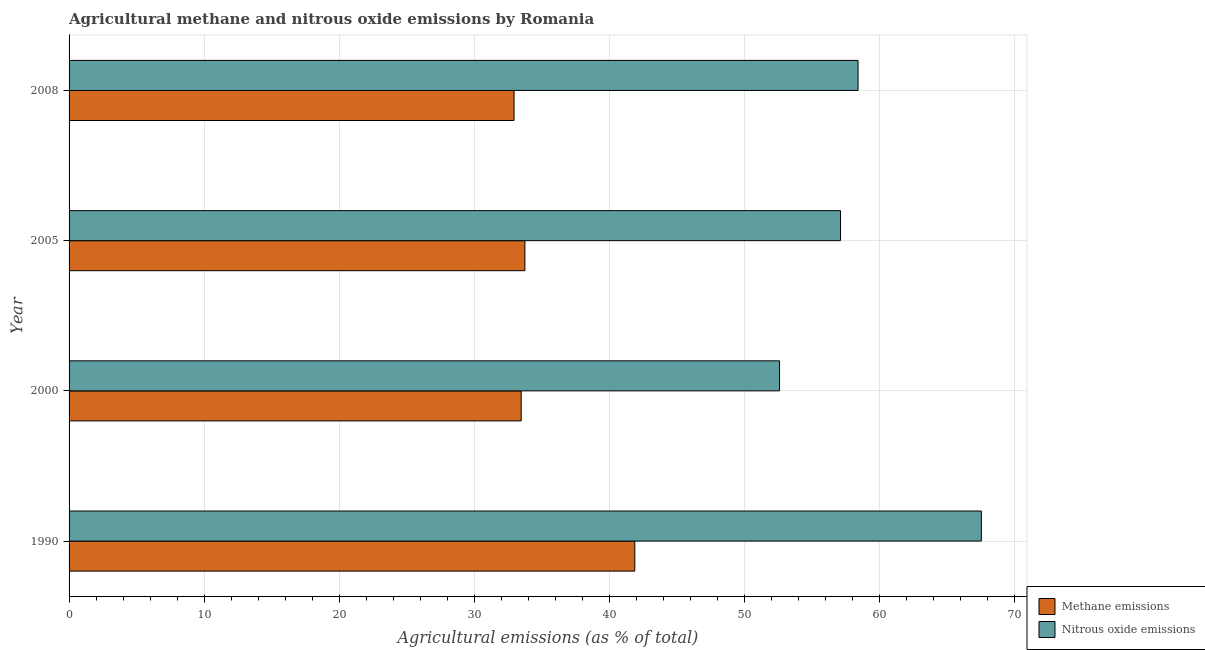How many bars are there on the 1st tick from the top?
Ensure brevity in your answer.  2. How many bars are there on the 3rd tick from the bottom?
Give a very brief answer. 2. What is the amount of methane emissions in 1990?
Ensure brevity in your answer.  41.87. Across all years, what is the maximum amount of methane emissions?
Your answer should be very brief. 41.87. Across all years, what is the minimum amount of methane emissions?
Provide a short and direct response. 32.94. In which year was the amount of nitrous oxide emissions minimum?
Provide a short and direct response. 2000. What is the total amount of nitrous oxide emissions in the graph?
Make the answer very short. 235.61. What is the difference between the amount of nitrous oxide emissions in 2000 and that in 2005?
Your answer should be very brief. -4.51. What is the difference between the amount of methane emissions in 2000 and the amount of nitrous oxide emissions in 2005?
Make the answer very short. -23.64. What is the average amount of methane emissions per year?
Your response must be concise. 35.5. In the year 1990, what is the difference between the amount of nitrous oxide emissions and amount of methane emissions?
Offer a very short reply. 25.65. In how many years, is the amount of methane emissions greater than 62 %?
Provide a succinct answer. 0. What is the ratio of the amount of nitrous oxide emissions in 2000 to that in 2008?
Ensure brevity in your answer.  0.9. Is the difference between the amount of nitrous oxide emissions in 1990 and 2000 greater than the difference between the amount of methane emissions in 1990 and 2000?
Your answer should be very brief. Yes. What is the difference between the highest and the second highest amount of methane emissions?
Keep it short and to the point. 8.13. What is the difference between the highest and the lowest amount of methane emissions?
Your answer should be very brief. 8.94. In how many years, is the amount of methane emissions greater than the average amount of methane emissions taken over all years?
Provide a short and direct response. 1. Is the sum of the amount of nitrous oxide emissions in 1990 and 2005 greater than the maximum amount of methane emissions across all years?
Keep it short and to the point. Yes. What does the 2nd bar from the top in 2000 represents?
Provide a short and direct response. Methane emissions. What does the 1st bar from the bottom in 1990 represents?
Your answer should be very brief. Methane emissions. How many bars are there?
Your answer should be very brief. 8. Are all the bars in the graph horizontal?
Your response must be concise. Yes. How many years are there in the graph?
Provide a short and direct response. 4. What is the difference between two consecutive major ticks on the X-axis?
Make the answer very short. 10. Are the values on the major ticks of X-axis written in scientific E-notation?
Your response must be concise. No. Does the graph contain any zero values?
Offer a very short reply. No. Does the graph contain grids?
Provide a short and direct response. Yes. Where does the legend appear in the graph?
Keep it short and to the point. Bottom right. How many legend labels are there?
Keep it short and to the point. 2. What is the title of the graph?
Offer a very short reply. Agricultural methane and nitrous oxide emissions by Romania. Does "Gasoline" appear as one of the legend labels in the graph?
Give a very brief answer. No. What is the label or title of the X-axis?
Give a very brief answer. Agricultural emissions (as % of total). What is the label or title of the Y-axis?
Your answer should be compact. Year. What is the Agricultural emissions (as % of total) in Methane emissions in 1990?
Make the answer very short. 41.87. What is the Agricultural emissions (as % of total) of Nitrous oxide emissions in 1990?
Provide a succinct answer. 67.52. What is the Agricultural emissions (as % of total) in Methane emissions in 2000?
Offer a terse response. 33.46. What is the Agricultural emissions (as % of total) of Nitrous oxide emissions in 2000?
Make the answer very short. 52.59. What is the Agricultural emissions (as % of total) of Methane emissions in 2005?
Ensure brevity in your answer.  33.74. What is the Agricultural emissions (as % of total) of Nitrous oxide emissions in 2005?
Give a very brief answer. 57.1. What is the Agricultural emissions (as % of total) in Methane emissions in 2008?
Your answer should be very brief. 32.94. What is the Agricultural emissions (as % of total) in Nitrous oxide emissions in 2008?
Your response must be concise. 58.4. Across all years, what is the maximum Agricultural emissions (as % of total) of Methane emissions?
Provide a short and direct response. 41.87. Across all years, what is the maximum Agricultural emissions (as % of total) of Nitrous oxide emissions?
Your answer should be compact. 67.52. Across all years, what is the minimum Agricultural emissions (as % of total) in Methane emissions?
Keep it short and to the point. 32.94. Across all years, what is the minimum Agricultural emissions (as % of total) in Nitrous oxide emissions?
Provide a succinct answer. 52.59. What is the total Agricultural emissions (as % of total) in Methane emissions in the graph?
Provide a succinct answer. 142.01. What is the total Agricultural emissions (as % of total) of Nitrous oxide emissions in the graph?
Offer a terse response. 235.61. What is the difference between the Agricultural emissions (as % of total) of Methane emissions in 1990 and that in 2000?
Offer a very short reply. 8.41. What is the difference between the Agricultural emissions (as % of total) in Nitrous oxide emissions in 1990 and that in 2000?
Offer a very short reply. 14.94. What is the difference between the Agricultural emissions (as % of total) in Methane emissions in 1990 and that in 2005?
Offer a terse response. 8.13. What is the difference between the Agricultural emissions (as % of total) in Nitrous oxide emissions in 1990 and that in 2005?
Offer a very short reply. 10.42. What is the difference between the Agricultural emissions (as % of total) of Methane emissions in 1990 and that in 2008?
Ensure brevity in your answer.  8.94. What is the difference between the Agricultural emissions (as % of total) in Nitrous oxide emissions in 1990 and that in 2008?
Your answer should be compact. 9.13. What is the difference between the Agricultural emissions (as % of total) in Methane emissions in 2000 and that in 2005?
Offer a terse response. -0.27. What is the difference between the Agricultural emissions (as % of total) in Nitrous oxide emissions in 2000 and that in 2005?
Your answer should be compact. -4.51. What is the difference between the Agricultural emissions (as % of total) of Methane emissions in 2000 and that in 2008?
Offer a terse response. 0.53. What is the difference between the Agricultural emissions (as % of total) of Nitrous oxide emissions in 2000 and that in 2008?
Offer a terse response. -5.81. What is the difference between the Agricultural emissions (as % of total) of Methane emissions in 2005 and that in 2008?
Give a very brief answer. 0.8. What is the difference between the Agricultural emissions (as % of total) of Nitrous oxide emissions in 2005 and that in 2008?
Your answer should be compact. -1.3. What is the difference between the Agricultural emissions (as % of total) of Methane emissions in 1990 and the Agricultural emissions (as % of total) of Nitrous oxide emissions in 2000?
Give a very brief answer. -10.71. What is the difference between the Agricultural emissions (as % of total) in Methane emissions in 1990 and the Agricultural emissions (as % of total) in Nitrous oxide emissions in 2005?
Keep it short and to the point. -15.23. What is the difference between the Agricultural emissions (as % of total) in Methane emissions in 1990 and the Agricultural emissions (as % of total) in Nitrous oxide emissions in 2008?
Your answer should be compact. -16.52. What is the difference between the Agricultural emissions (as % of total) in Methane emissions in 2000 and the Agricultural emissions (as % of total) in Nitrous oxide emissions in 2005?
Your answer should be very brief. -23.64. What is the difference between the Agricultural emissions (as % of total) in Methane emissions in 2000 and the Agricultural emissions (as % of total) in Nitrous oxide emissions in 2008?
Offer a very short reply. -24.93. What is the difference between the Agricultural emissions (as % of total) of Methane emissions in 2005 and the Agricultural emissions (as % of total) of Nitrous oxide emissions in 2008?
Offer a very short reply. -24.66. What is the average Agricultural emissions (as % of total) in Methane emissions per year?
Keep it short and to the point. 35.5. What is the average Agricultural emissions (as % of total) in Nitrous oxide emissions per year?
Keep it short and to the point. 58.9. In the year 1990, what is the difference between the Agricultural emissions (as % of total) of Methane emissions and Agricultural emissions (as % of total) of Nitrous oxide emissions?
Offer a very short reply. -25.65. In the year 2000, what is the difference between the Agricultural emissions (as % of total) of Methane emissions and Agricultural emissions (as % of total) of Nitrous oxide emissions?
Provide a succinct answer. -19.12. In the year 2005, what is the difference between the Agricultural emissions (as % of total) of Methane emissions and Agricultural emissions (as % of total) of Nitrous oxide emissions?
Your answer should be very brief. -23.36. In the year 2008, what is the difference between the Agricultural emissions (as % of total) of Methane emissions and Agricultural emissions (as % of total) of Nitrous oxide emissions?
Provide a short and direct response. -25.46. What is the ratio of the Agricultural emissions (as % of total) in Methane emissions in 1990 to that in 2000?
Provide a succinct answer. 1.25. What is the ratio of the Agricultural emissions (as % of total) of Nitrous oxide emissions in 1990 to that in 2000?
Your response must be concise. 1.28. What is the ratio of the Agricultural emissions (as % of total) in Methane emissions in 1990 to that in 2005?
Your answer should be very brief. 1.24. What is the ratio of the Agricultural emissions (as % of total) in Nitrous oxide emissions in 1990 to that in 2005?
Your answer should be very brief. 1.18. What is the ratio of the Agricultural emissions (as % of total) of Methane emissions in 1990 to that in 2008?
Offer a terse response. 1.27. What is the ratio of the Agricultural emissions (as % of total) in Nitrous oxide emissions in 1990 to that in 2008?
Offer a terse response. 1.16. What is the ratio of the Agricultural emissions (as % of total) in Methane emissions in 2000 to that in 2005?
Keep it short and to the point. 0.99. What is the ratio of the Agricultural emissions (as % of total) of Nitrous oxide emissions in 2000 to that in 2005?
Make the answer very short. 0.92. What is the ratio of the Agricultural emissions (as % of total) of Methane emissions in 2000 to that in 2008?
Offer a very short reply. 1.02. What is the ratio of the Agricultural emissions (as % of total) of Nitrous oxide emissions in 2000 to that in 2008?
Make the answer very short. 0.9. What is the ratio of the Agricultural emissions (as % of total) in Methane emissions in 2005 to that in 2008?
Provide a short and direct response. 1.02. What is the ratio of the Agricultural emissions (as % of total) in Nitrous oxide emissions in 2005 to that in 2008?
Ensure brevity in your answer.  0.98. What is the difference between the highest and the second highest Agricultural emissions (as % of total) in Methane emissions?
Your answer should be very brief. 8.13. What is the difference between the highest and the second highest Agricultural emissions (as % of total) of Nitrous oxide emissions?
Offer a very short reply. 9.13. What is the difference between the highest and the lowest Agricultural emissions (as % of total) of Methane emissions?
Offer a very short reply. 8.94. What is the difference between the highest and the lowest Agricultural emissions (as % of total) of Nitrous oxide emissions?
Keep it short and to the point. 14.94. 